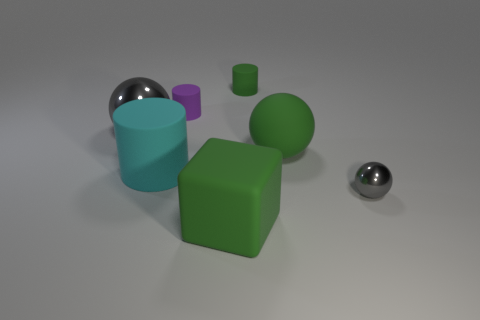Add 2 small brown rubber things. How many objects exist? 9 Subtract all cubes. How many objects are left? 6 Add 6 large cyan objects. How many large cyan objects are left? 7 Add 2 cyan matte objects. How many cyan matte objects exist? 3 Subtract 0 yellow cylinders. How many objects are left? 7 Subtract all green spheres. Subtract all large shiny balls. How many objects are left? 5 